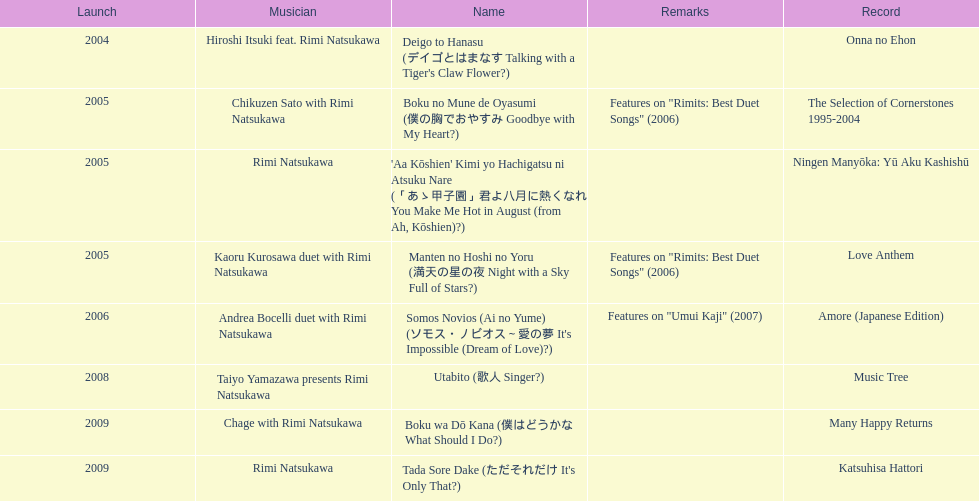What is the last title released? 2009. 